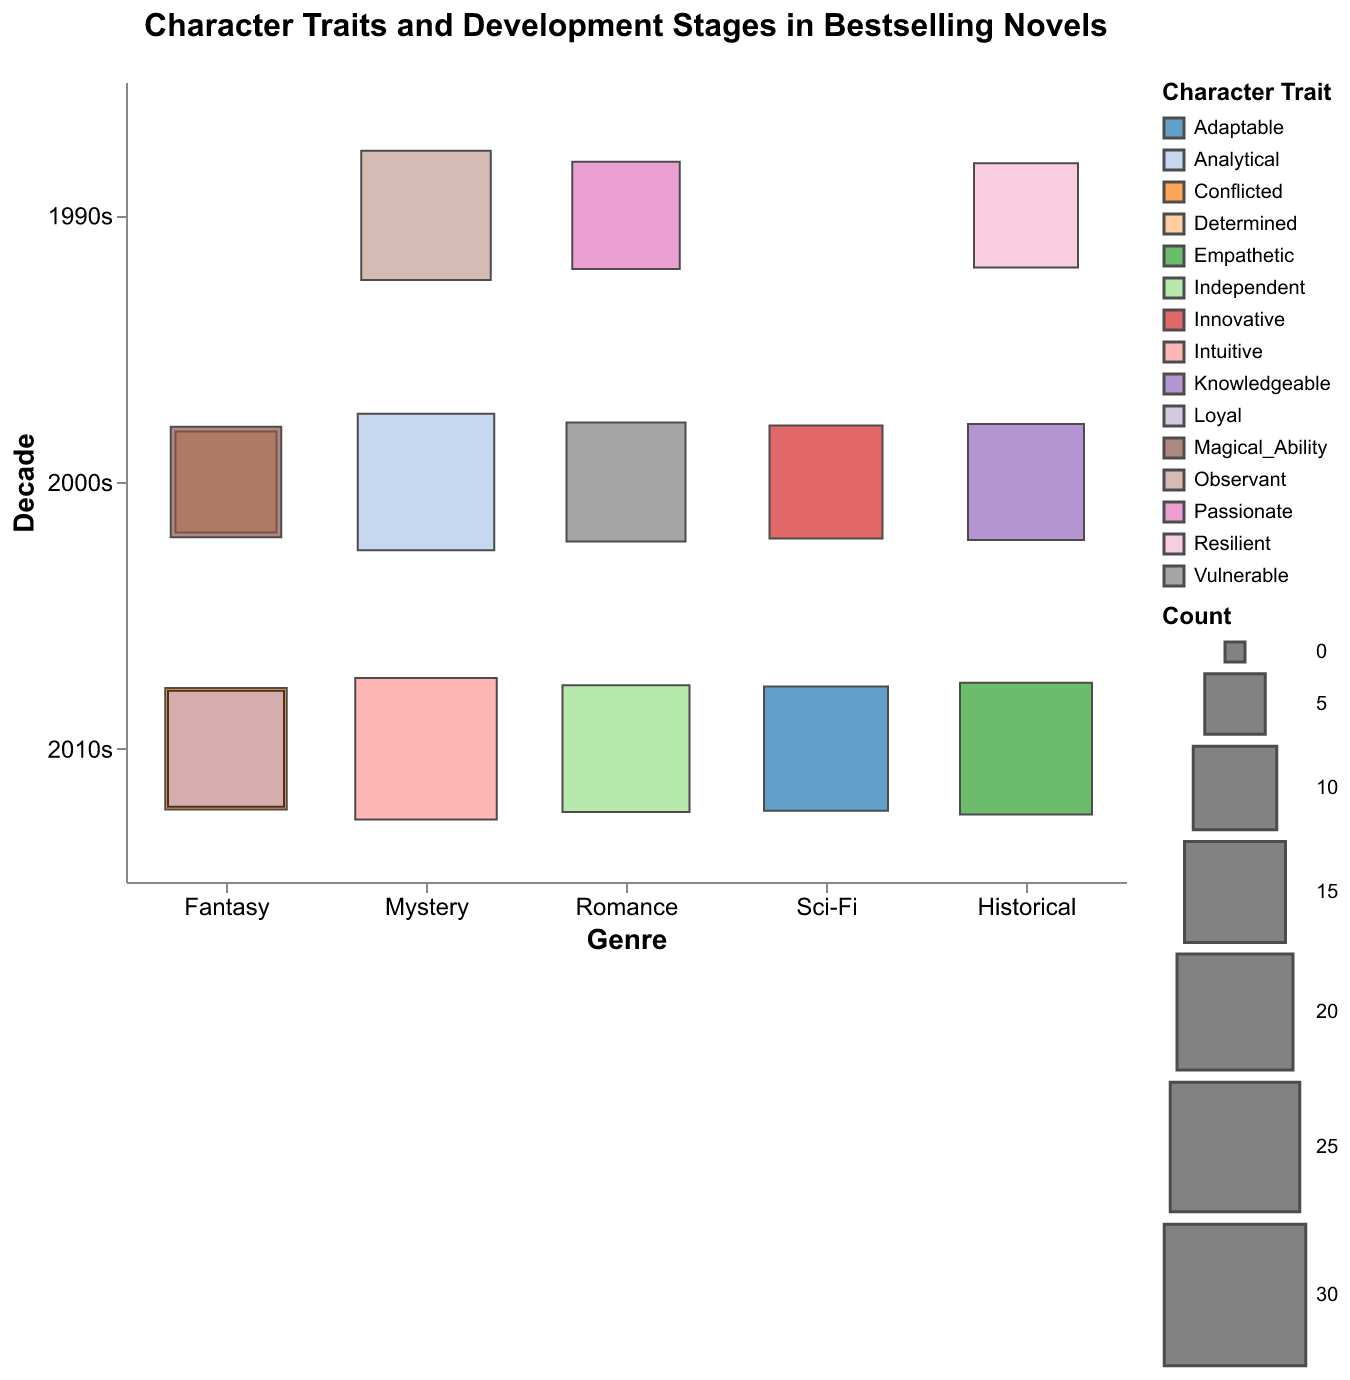What are the character traits depicted in Fantasy novels during the 2010s? To find the character traits depicted in Fantasy novels during the 2010s, locate the intersection of the "Fantasy" genre on the x-axis and the "2010s" decade on the y-axis, then identify the character traits labeled in the color legend.
Answer: Conflicted, Loyal Which genre in the 2010s has the highest count of novels featuring a specific character trait and development stage? To determine which genre in the 2010s has the highest count, locate the "2010s" decade on the y-axis, then compare the sizes of the squares for each genre. The largest square indicates the highest count.
Answer: Mystery How does the character trait "Resilient" in Historical novels compare between the 1990s and the 2000s? Identify the "Historical" genre on the x-axis and look at the squares representing the 1990s and 2000s on the y-axis. Note the sizes of the squares corresponding to "Resilient" character trait.
Answer: 1990s has 16, 2000s has 0 Which development stage is most associated with the "Vulnerable" character trait in Romance novels during the 2000s? To find this, locate "Romance" on the x-axis and the "2000s" on the y-axis, then identify the development stage labeled in the color legend for "Vulnerable."
Answer: Emotional Growth What is the average count of novels in the "Fantasy" genre across all decades? To calculate the average, add the counts of novels in the Fantasy genre across all decades and divide by the number of decades. The counts are 15, 18, 22, and 20. Sum these counts (15+18+22+20=75) and divide by 4.
Answer: 18.75 How many development stages are depicted in all genres during the 2000s? Locate the rows for the 2000s on the y-axis and count the number of distinct squares for all genres, each representing a development stage.
Answer: 5 Which genre had the highest variety of character traits represented in the 2010s? Look at the "2010s" decade on the y-axis and count the number of different character traits for each genre as indicated by the color legend. The genre with the most different colors has the highest variety.
Answer: Fantasy In the Mystery genre, which decade shows the highest number of novels featuring the "Observant" trait? Locate the "Mystery" genre on the x-axis and compare the square sizes across decades for the "Observant" trait in the color legend.
Answer: 1990s For which genre and decade combination do the "Knowledgeable" trait and "Research Phase" development stage appear? Identify the "Knowledgeable" trait and "Research Phase" development stage in the legend, then find the corresponding square to see which genre and decade it is displayed for.
Answer: Historical, 2000s 